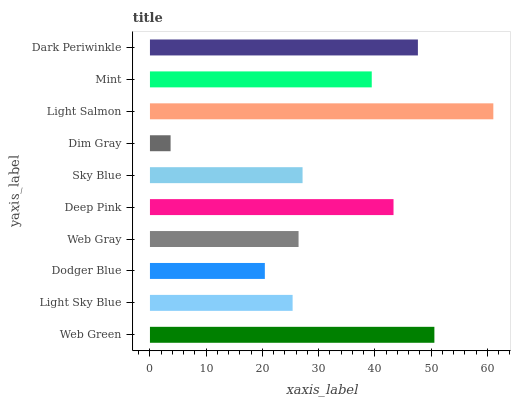Is Dim Gray the minimum?
Answer yes or no. Yes. Is Light Salmon the maximum?
Answer yes or no. Yes. Is Light Sky Blue the minimum?
Answer yes or no. No. Is Light Sky Blue the maximum?
Answer yes or no. No. Is Web Green greater than Light Sky Blue?
Answer yes or no. Yes. Is Light Sky Blue less than Web Green?
Answer yes or no. Yes. Is Light Sky Blue greater than Web Green?
Answer yes or no. No. Is Web Green less than Light Sky Blue?
Answer yes or no. No. Is Mint the high median?
Answer yes or no. Yes. Is Sky Blue the low median?
Answer yes or no. Yes. Is Sky Blue the high median?
Answer yes or no. No. Is Web Gray the low median?
Answer yes or no. No. 